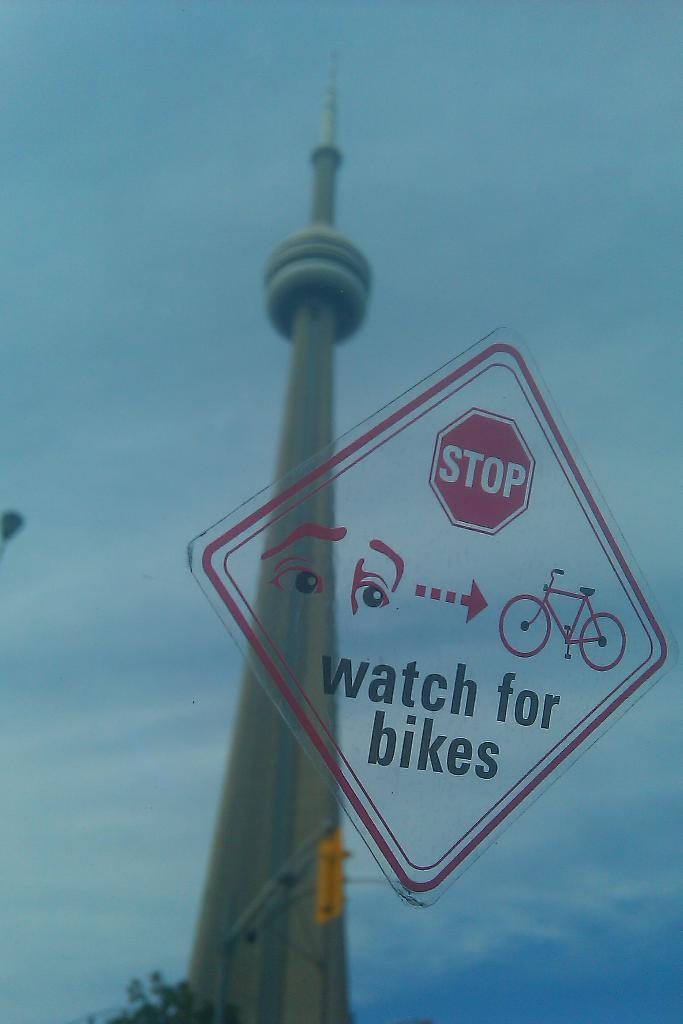<image>
Provide a brief description of the given image. A sign that says Stop watch for bikes is overlaid on a picture of a monument. 